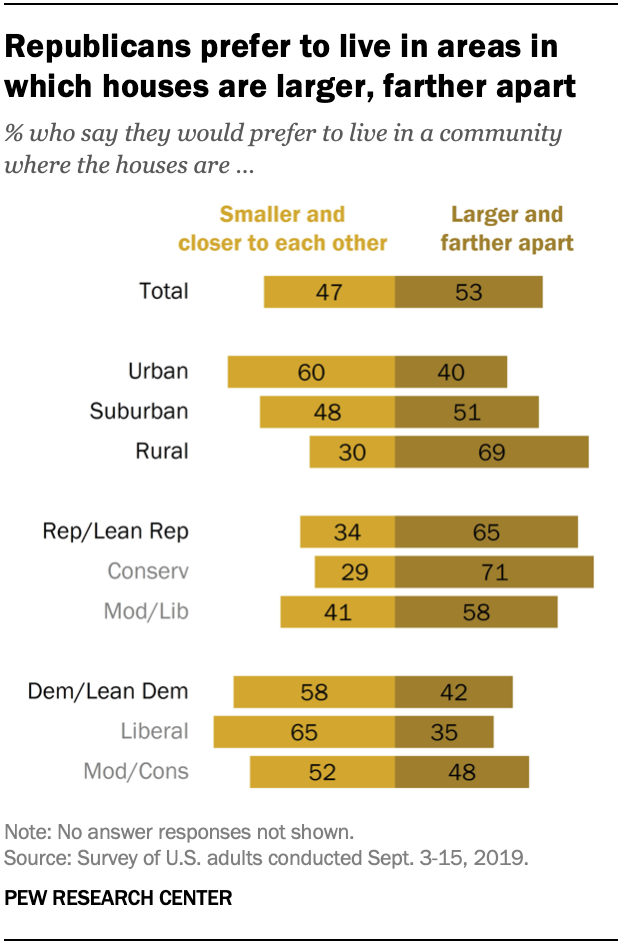Highlight a few significant elements in this photo. In urban areas, approximately 40% of people prefer larger and farther apart housing options. The difference in the value of rural and urban residents who want larger and farther apart homes is 29%. 